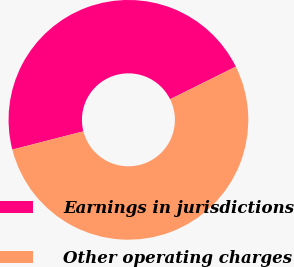Convert chart. <chart><loc_0><loc_0><loc_500><loc_500><pie_chart><fcel>Earnings in jurisdictions<fcel>Other operating charges<nl><fcel>46.67%<fcel>53.33%<nl></chart> 